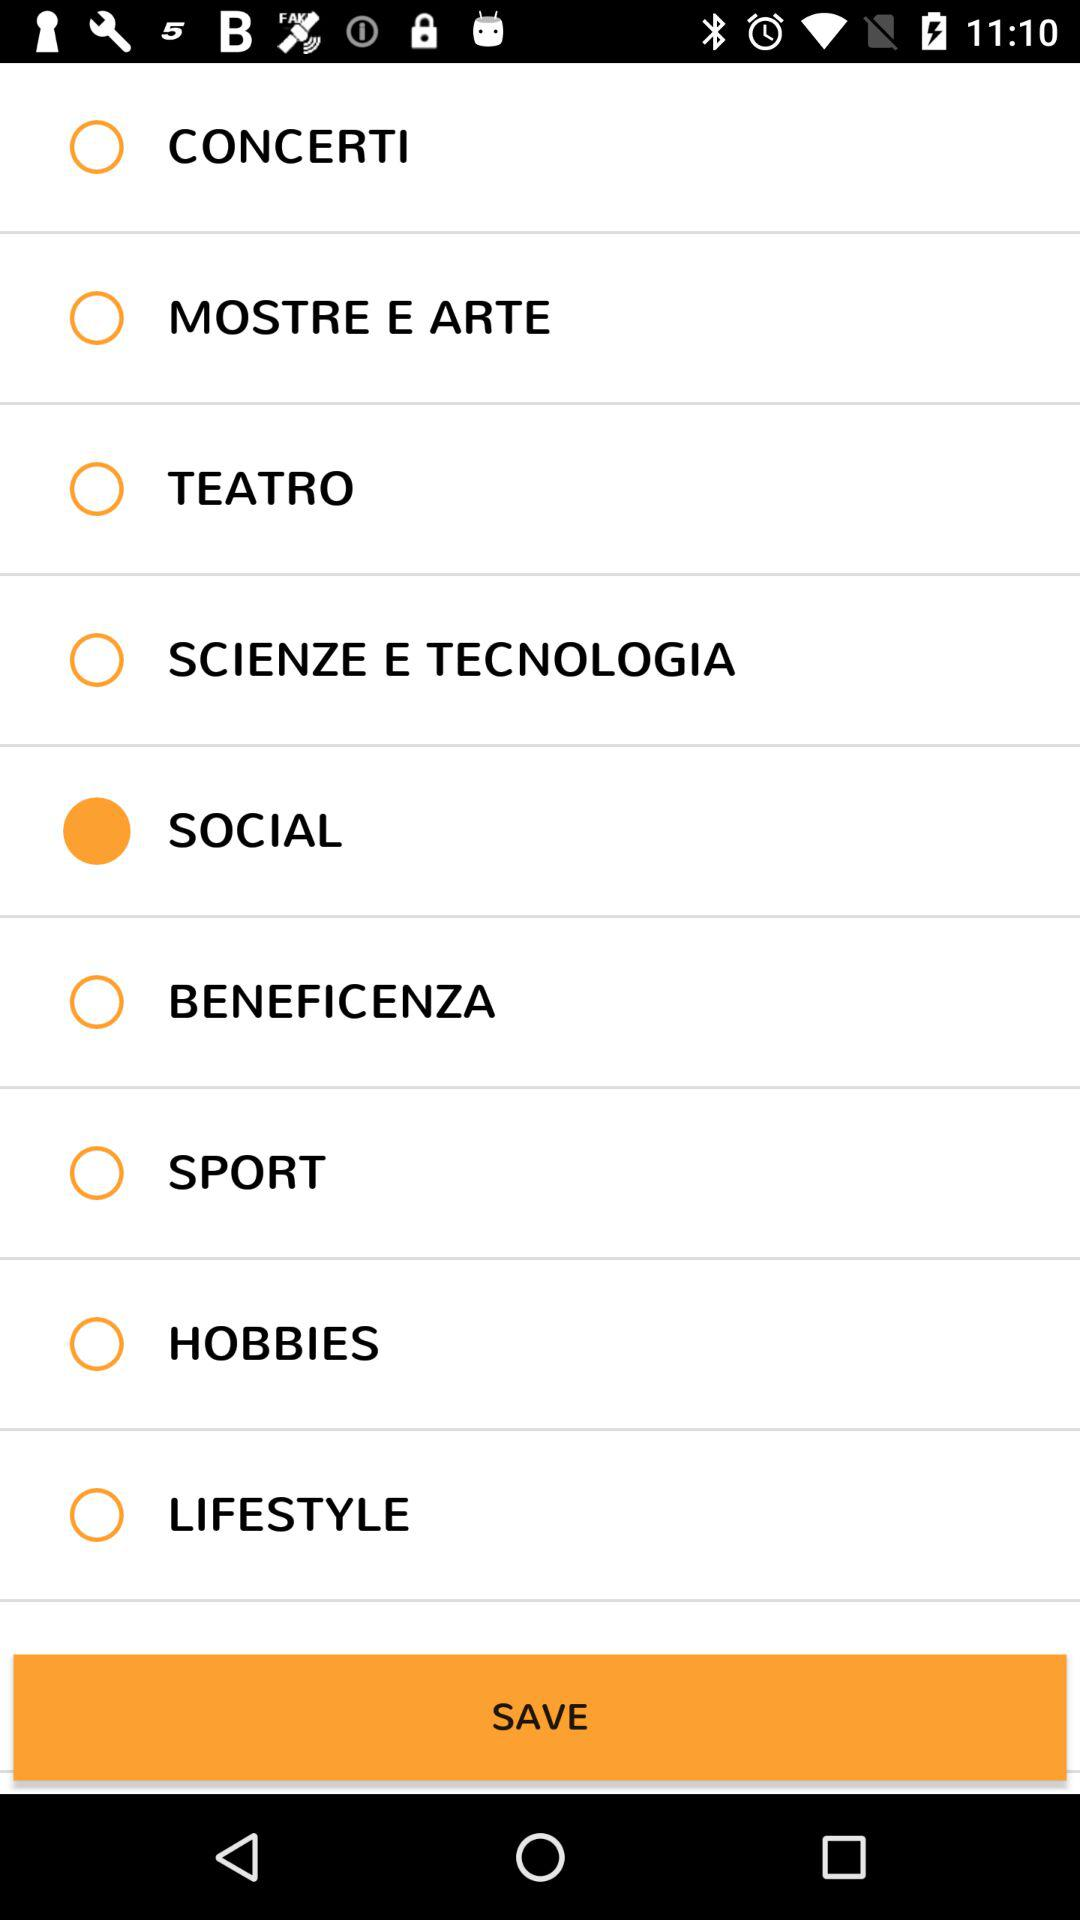What alert is shown on the "Email or phone" option? The alert is that this account already exists on your device. 